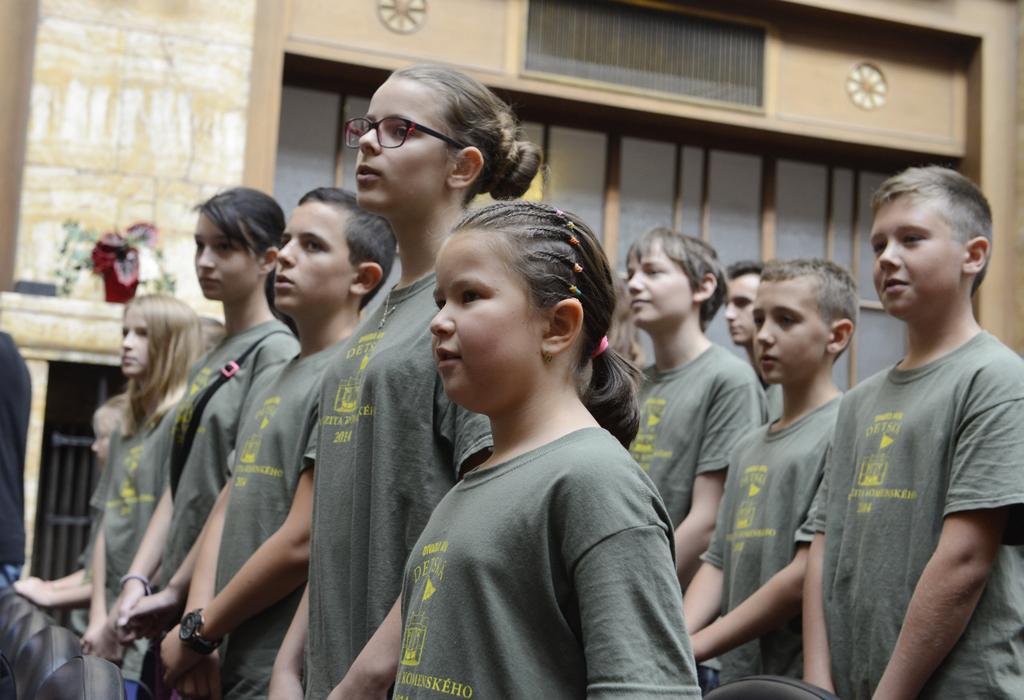Could you give a brief overview of what you see in this image? In the middle of the image few people are standing. Behind them there is wall. 